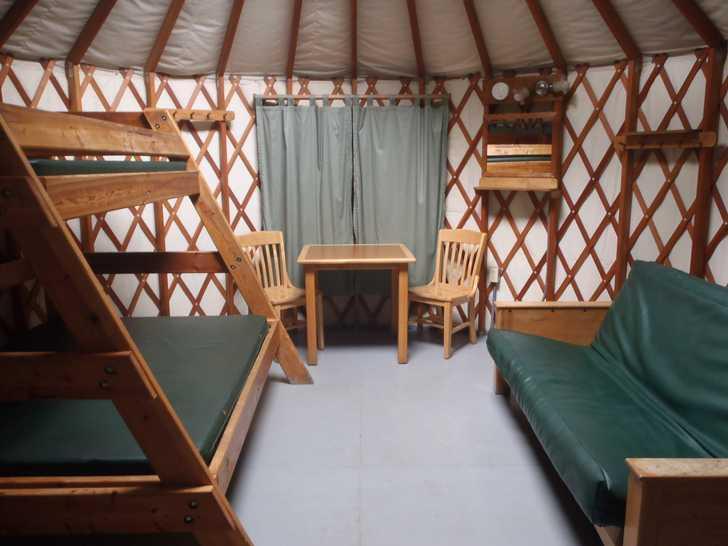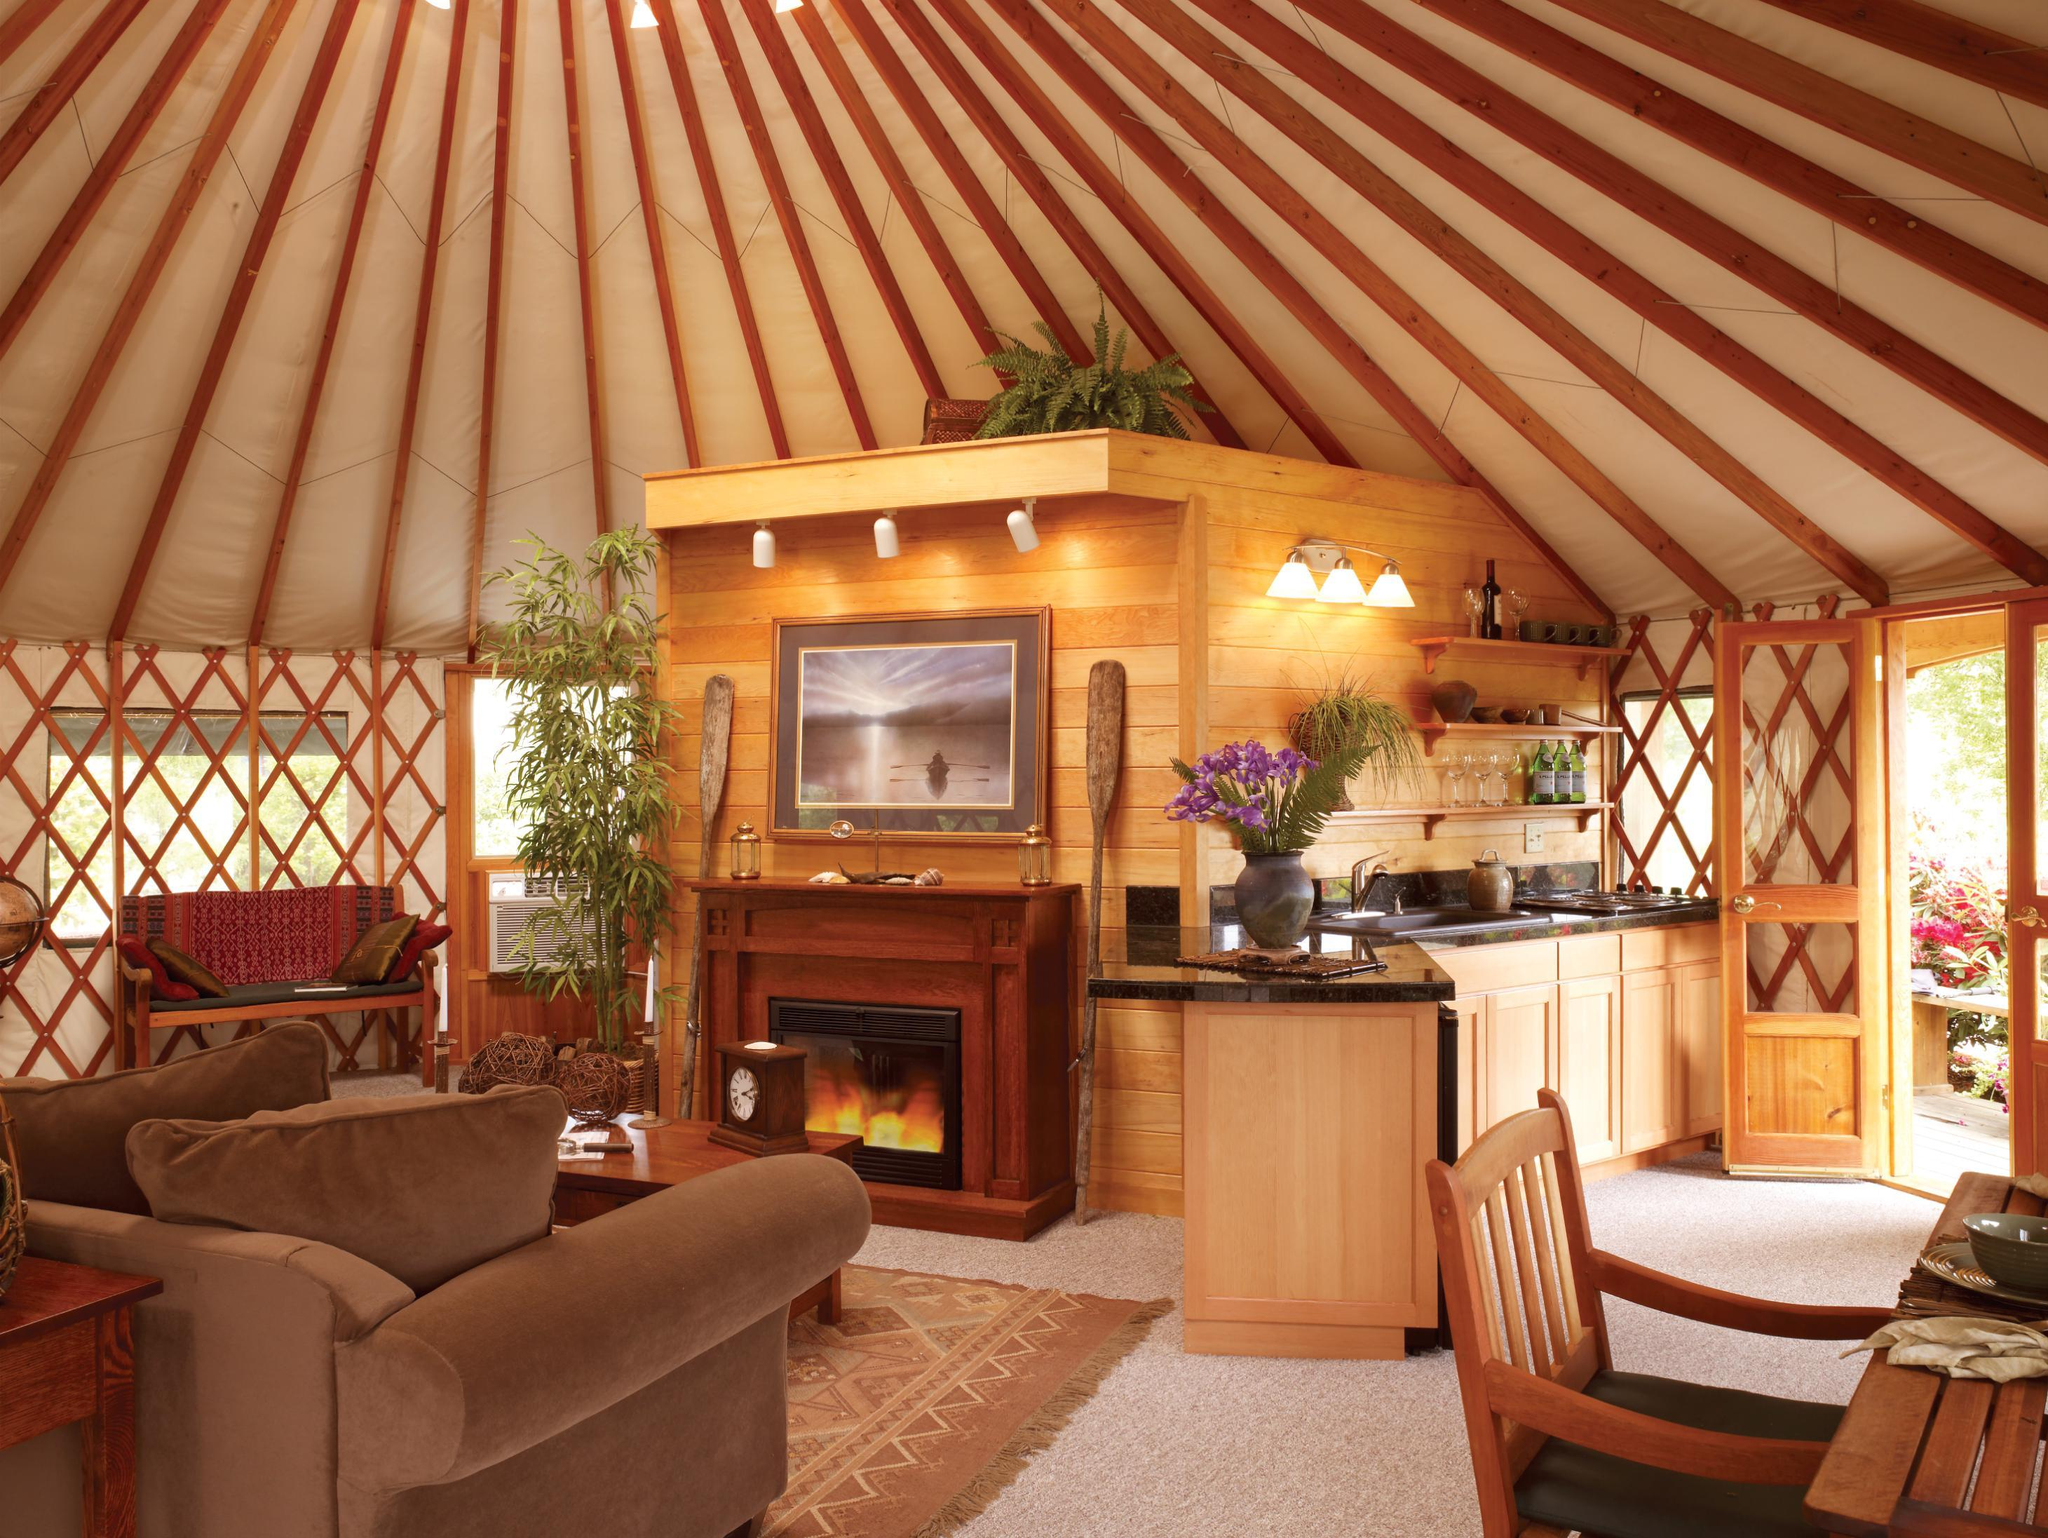The first image is the image on the left, the second image is the image on the right. Assess this claim about the two images: "At least one image shows a room with facing futon and angled bunk.". Correct or not? Answer yes or no. Yes. The first image is the image on the left, the second image is the image on the right. For the images shown, is this caption "At least one image is of a sleeping area in a round house." true? Answer yes or no. Yes. 